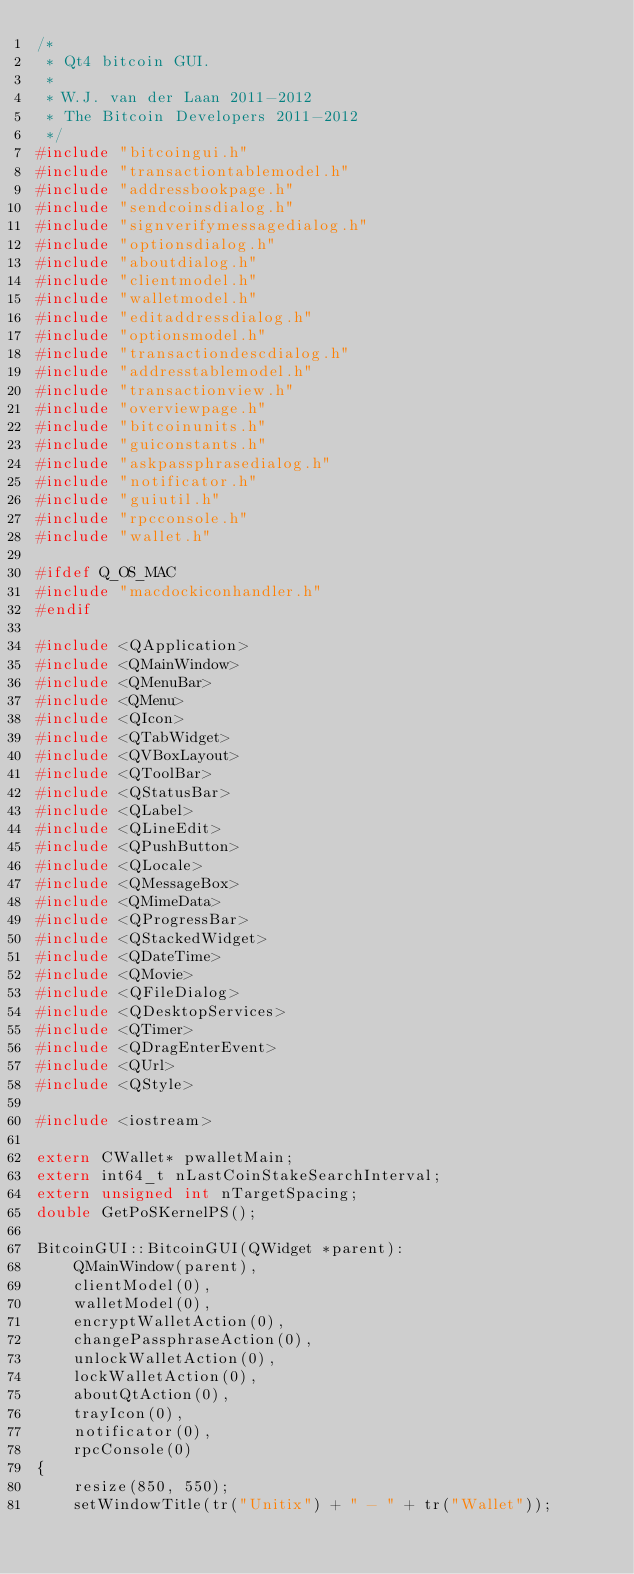<code> <loc_0><loc_0><loc_500><loc_500><_C++_>/*
 * Qt4 bitcoin GUI.
 *
 * W.J. van der Laan 2011-2012
 * The Bitcoin Developers 2011-2012
 */
#include "bitcoingui.h"
#include "transactiontablemodel.h"
#include "addressbookpage.h"
#include "sendcoinsdialog.h"
#include "signverifymessagedialog.h"
#include "optionsdialog.h"
#include "aboutdialog.h"
#include "clientmodel.h"
#include "walletmodel.h"
#include "editaddressdialog.h"
#include "optionsmodel.h"
#include "transactiondescdialog.h"
#include "addresstablemodel.h"
#include "transactionview.h"
#include "overviewpage.h"
#include "bitcoinunits.h"
#include "guiconstants.h"
#include "askpassphrasedialog.h"
#include "notificator.h"
#include "guiutil.h"
#include "rpcconsole.h"
#include "wallet.h"

#ifdef Q_OS_MAC
#include "macdockiconhandler.h"
#endif

#include <QApplication>
#include <QMainWindow>
#include <QMenuBar>
#include <QMenu>
#include <QIcon>
#include <QTabWidget>
#include <QVBoxLayout>
#include <QToolBar>
#include <QStatusBar>
#include <QLabel>
#include <QLineEdit>
#include <QPushButton>
#include <QLocale>
#include <QMessageBox>
#include <QMimeData>
#include <QProgressBar>
#include <QStackedWidget>
#include <QDateTime>
#include <QMovie>
#include <QFileDialog>
#include <QDesktopServices>
#include <QTimer>
#include <QDragEnterEvent>
#include <QUrl>
#include <QStyle>

#include <iostream>

extern CWallet* pwalletMain;
extern int64_t nLastCoinStakeSearchInterval;
extern unsigned int nTargetSpacing;
double GetPoSKernelPS();

BitcoinGUI::BitcoinGUI(QWidget *parent):
    QMainWindow(parent),
    clientModel(0),
    walletModel(0),
    encryptWalletAction(0),
    changePassphraseAction(0),
    unlockWalletAction(0),
    lockWalletAction(0),
    aboutQtAction(0),
    trayIcon(0),
    notificator(0),
    rpcConsole(0)
{
    resize(850, 550);
    setWindowTitle(tr("Unitix") + " - " + tr("Wallet"));</code> 